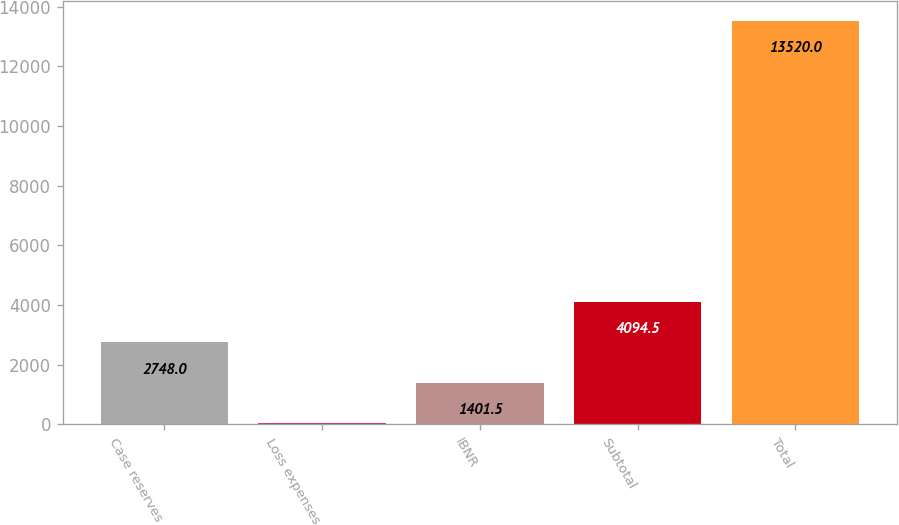Convert chart to OTSL. <chart><loc_0><loc_0><loc_500><loc_500><bar_chart><fcel>Case reserves<fcel>Loss expenses<fcel>IBNR<fcel>Subtotal<fcel>Total<nl><fcel>2748<fcel>55<fcel>1401.5<fcel>4094.5<fcel>13520<nl></chart> 